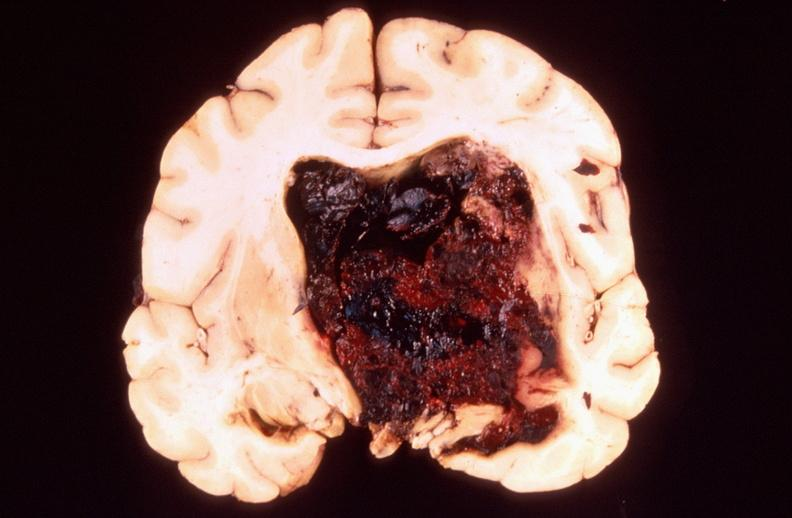what is present?
Answer the question using a single word or phrase. Nervous 